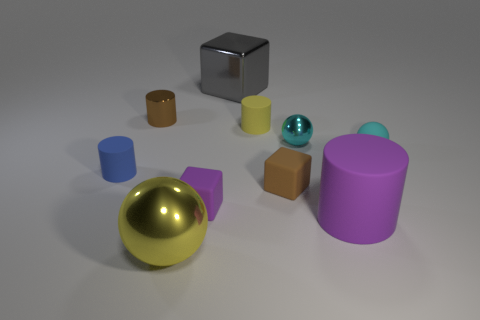Subtract all green cylinders. Subtract all gray blocks. How many cylinders are left? 4 Subtract all cubes. How many objects are left? 7 Add 9 large cylinders. How many large cylinders exist? 10 Subtract 0 green cubes. How many objects are left? 10 Subtract all gray cubes. Subtract all big gray cubes. How many objects are left? 8 Add 5 blue cylinders. How many blue cylinders are left? 6 